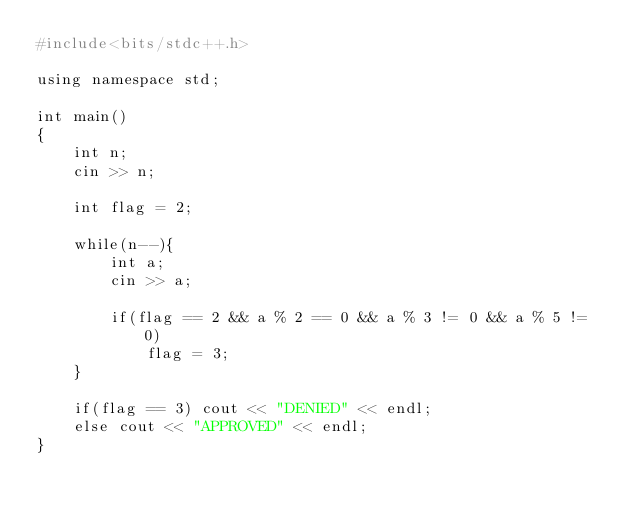<code> <loc_0><loc_0><loc_500><loc_500><_Awk_>#include<bits/stdc++.h>

using namespace std;

int main()
{
    int n;
    cin >> n;

    int flag = 2;

    while(n--){
        int a;
        cin >> a;

        if(flag == 2 && a % 2 == 0 && a % 3 != 0 && a % 5 != 0)
            flag = 3;
    }

    if(flag == 3) cout << "DENIED" << endl;
    else cout << "APPROVED" << endl;
}
</code> 